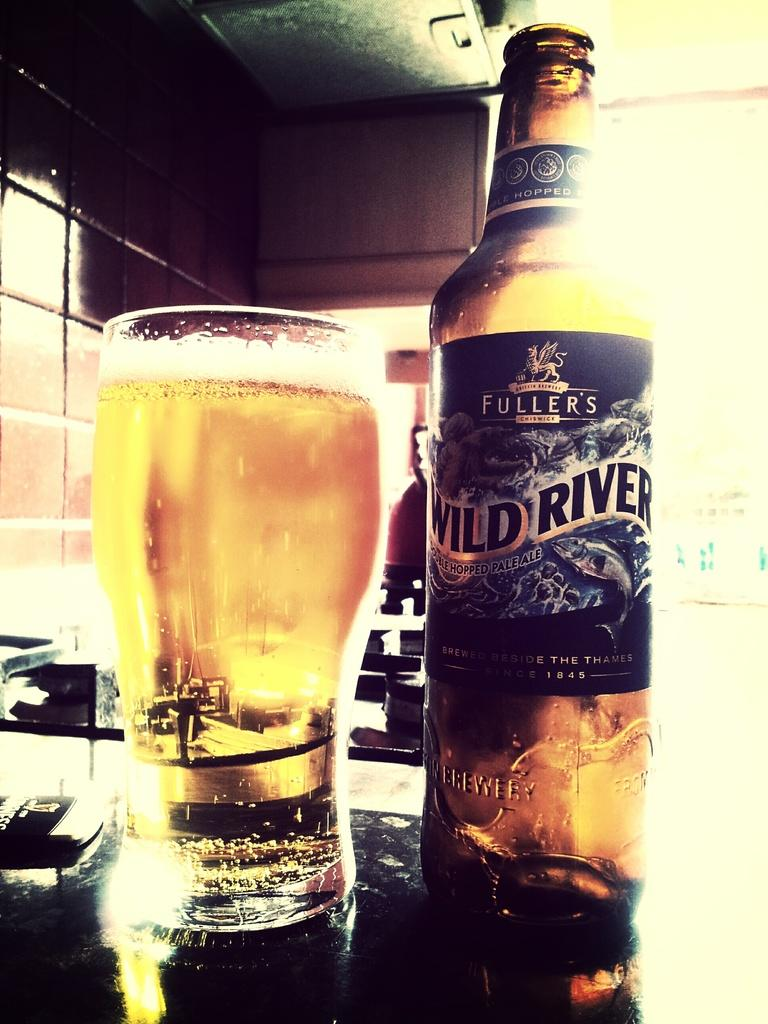<image>
Describe the image concisely. A glass full of light amber beer next to a bottle that states Fuller's Wild River. 